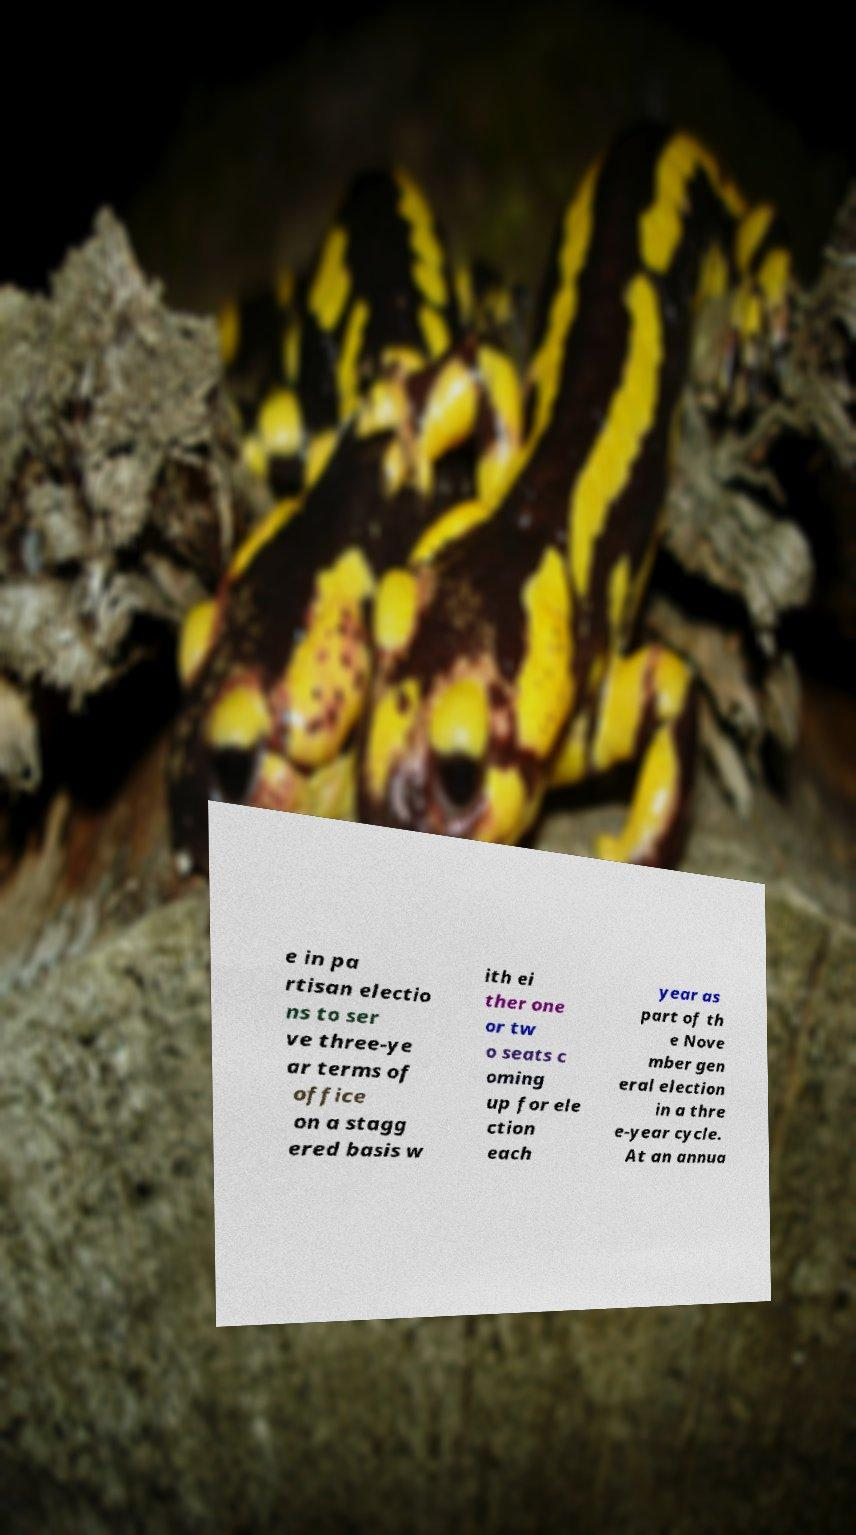Please read and relay the text visible in this image. What does it say? e in pa rtisan electio ns to ser ve three-ye ar terms of office on a stagg ered basis w ith ei ther one or tw o seats c oming up for ele ction each year as part of th e Nove mber gen eral election in a thre e-year cycle. At an annua 